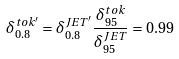<formula> <loc_0><loc_0><loc_500><loc_500>\delta _ { 0 . 8 } ^ { t o k ^ { \prime } } = \delta _ { 0 . 8 } ^ { J E T ^ { \prime } } \frac { \delta _ { 9 5 } ^ { t o k } } { \delta _ { 9 5 } ^ { J E T } } = 0 . 9 9</formula> 